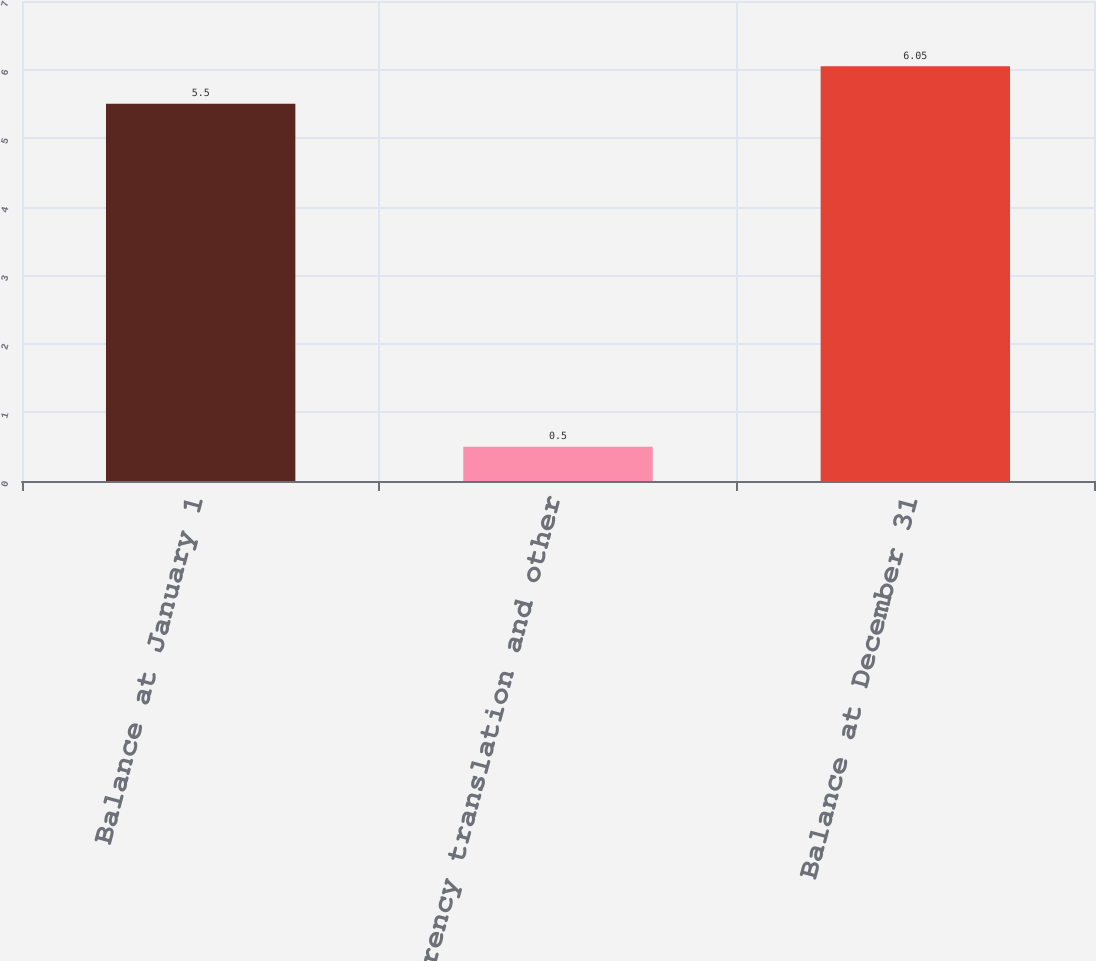Convert chart. <chart><loc_0><loc_0><loc_500><loc_500><bar_chart><fcel>Balance at January 1<fcel>Currency translation and other<fcel>Balance at December 31<nl><fcel>5.5<fcel>0.5<fcel>6.05<nl></chart> 